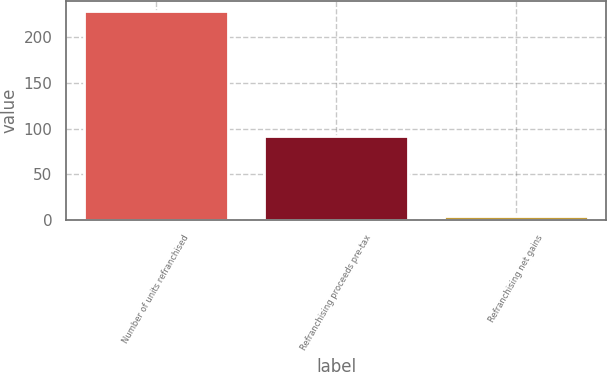Convert chart. <chart><loc_0><loc_0><loc_500><loc_500><bar_chart><fcel>Number of units refranchised<fcel>Refranchising proceeds pre-tax<fcel>Refranchising net gains<nl><fcel>228<fcel>92<fcel>4<nl></chart> 